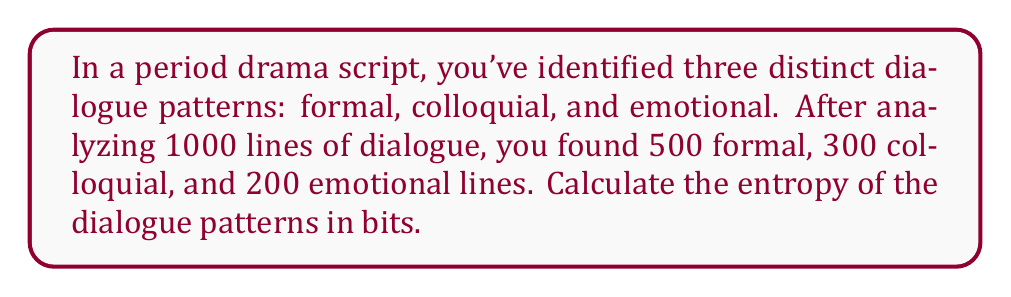Teach me how to tackle this problem. To calculate the entropy of the dialogue patterns, we'll use the Shannon entropy formula:

$$H = -\sum_{i=1}^{n} p_i \log_2(p_i)$$

Where $p_i$ is the probability of each dialogue pattern occurring.

Step 1: Calculate the probabilities for each dialogue pattern:
$p_{\text{formal}} = 500/1000 = 0.5$
$p_{\text{colloquial}} = 300/1000 = 0.3$
$p_{\text{emotional}} = 200/1000 = 0.2$

Step 2: Apply the entropy formula:

$$\begin{align}
H &= -(0.5 \log_2(0.5) + 0.3 \log_2(0.3) + 0.2 \log_2(0.2)) \\
&= -((0.5 \times -1) + (0.3 \times -1.737) + (0.2 \times -2.322)) \\
&= -((-0.5) + (-0.5211) + (-0.4644)) \\
&= 1.4855
\end{align}$$

Step 3: Round to three decimal places:
$H \approx 1.486$ bits
Answer: 1.486 bits 